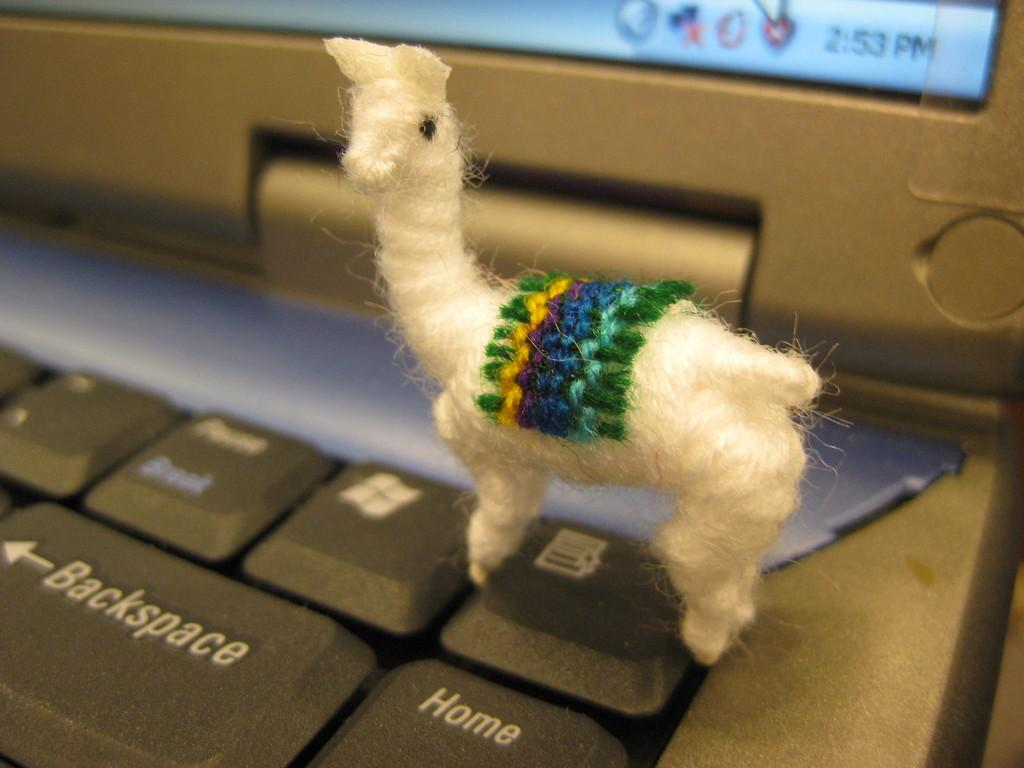What is the main object in the front of the image? There is a toy in the front of the image. What electronic device can be seen in the background of the image? There is a laptop in the background of the image. What part of the laptop is visible in the image? The laptop's keys are visible in the image. Are there any dinosaurs interacting with the toy in the image? No, there are no dinosaurs present in the image. What type of plant is growing next to the laptop in the image? There is no plant visible in the image; it only features a toy in the front and a laptop in the background. 